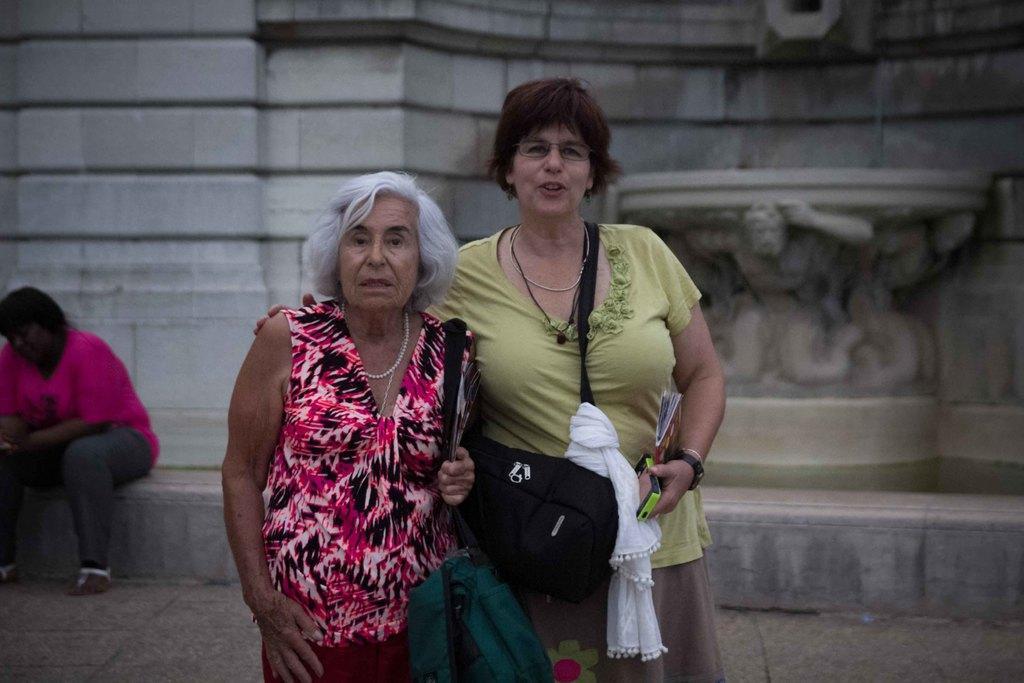Can you describe this image briefly? In this picture I can see that there are two people standing here and the are wearing handbags and holding some objects and in the background there is the person sitting here and there is a wall in the backdrop. 